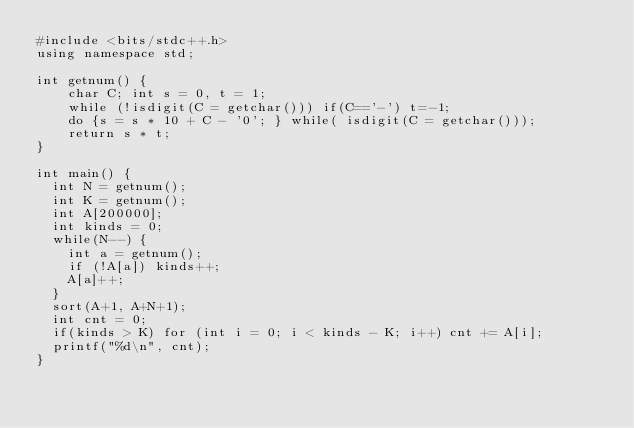Convert code to text. <code><loc_0><loc_0><loc_500><loc_500><_C++_>#include <bits/stdc++.h>
using namespace std;

int getnum() {
    char C; int s = 0, t = 1;
    while (!isdigit(C = getchar())) if(C=='-') t=-1;
    do {s = s * 10 + C - '0'; } while( isdigit(C = getchar()));
    return s * t;
}   

int main() {
  int N = getnum();
  int K = getnum();
  int A[200000];
  int kinds = 0;
  while(N--) {
    int a = getnum();
    if (!A[a]) kinds++;
    A[a]++;
  }
  sort(A+1, A+N+1);
  int cnt = 0;
  if(kinds > K) for (int i = 0; i < kinds - K; i++) cnt += A[i];
  printf("%d\n", cnt);
}</code> 